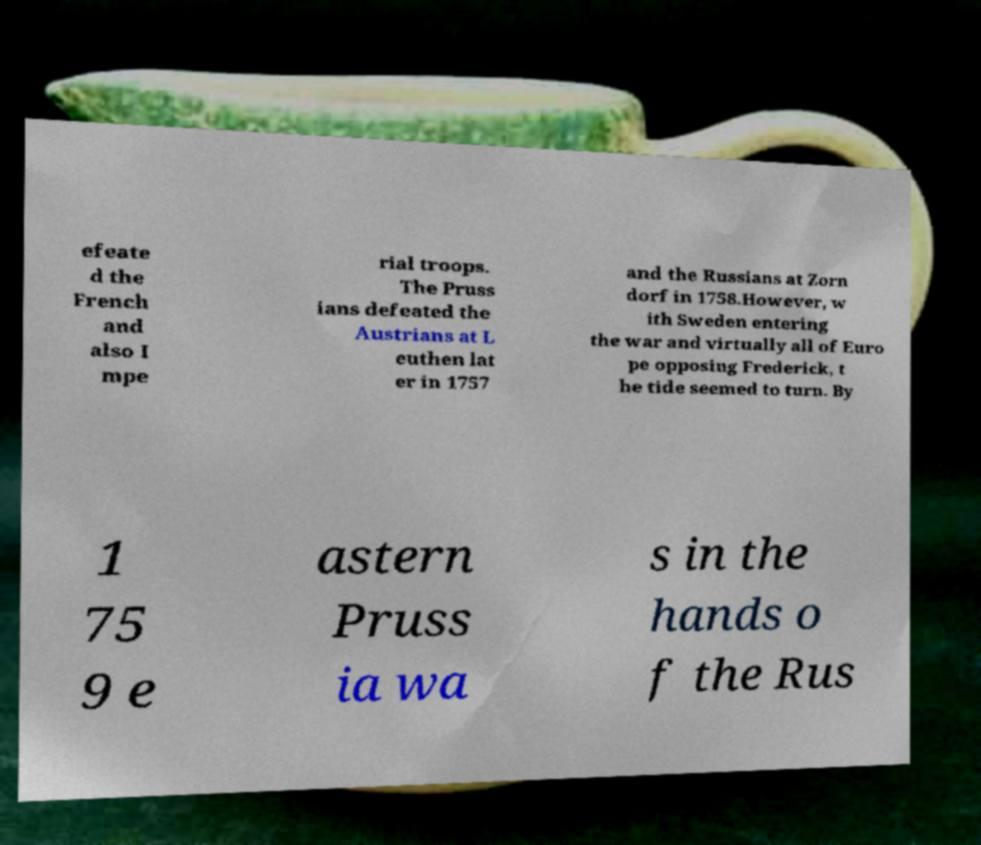Can you accurately transcribe the text from the provided image for me? efeate d the French and also I mpe rial troops. The Pruss ians defeated the Austrians at L euthen lat er in 1757 and the Russians at Zorn dorf in 1758.However, w ith Sweden entering the war and virtually all of Euro pe opposing Frederick, t he tide seemed to turn. By 1 75 9 e astern Pruss ia wa s in the hands o f the Rus 